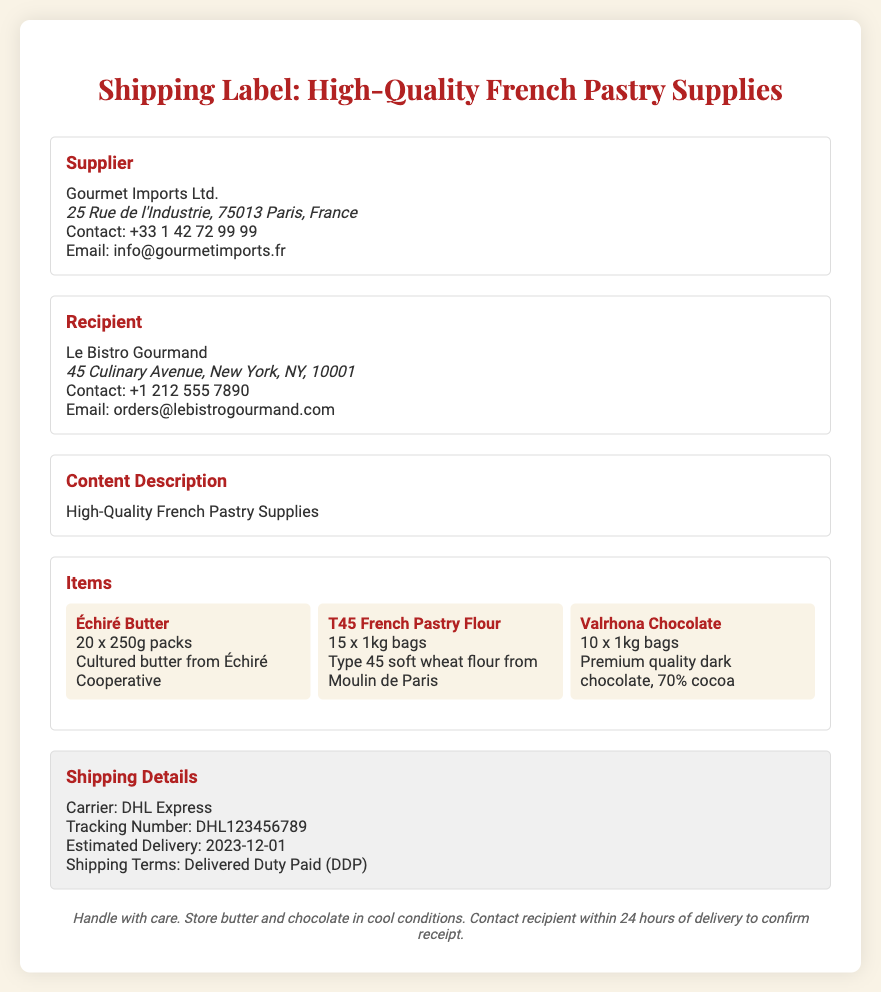What is the name of the supplier? The supplier's name is listed prominently in the document, which is "Gourmet Imports Ltd."
Answer: Gourmet Imports Ltd What is the address of the recipient? The recipient's address is clearly stated in the document as part of the contact information for Le Bistro Gourmand.
Answer: 45 Culinary Avenue, New York, NY, 10001 How many packs of Échiré Butter are included in the shipment? The document specifies the number of packs included for each item, stating that there are "20 x 250g packs" of Échiré Butter.
Answer: 20 What is the shipping carrier? The document notes the carrier responsible for the shipment in the shipping details section.
Answer: DHL Express What is the estimated delivery date? The estimated delivery date is given explicitly in the document under the shipping details section.
Answer: 2023-12-01 What is the type of the flour being shipped? The document describes the type of flour included in the shipment, which is specified as Type 45.
Answer: T45 French Pastry Flour How many bags of Valrhona Chocolate are included? The document lists the number of bags for each item, and for Valrhona Chocolate, it indicates "10 x 1kg bags."
Answer: 10 What is the contact email for the supplier? The contact email for the supplier is provided in the document, allowing for inquiries or concerns regarding the shipment.
Answer: info@gourmetimports.fr What terms of shipping are mentioned? The shipping terms are specifically identified in the shipping details segment of the document.
Answer: Delivered Duty Paid (DDP) 